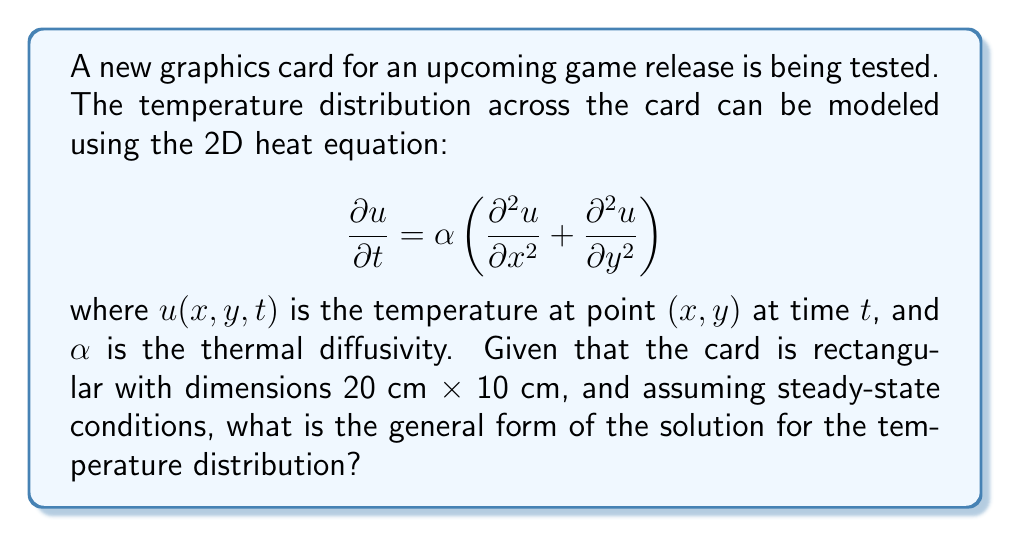Show me your answer to this math problem. To solve this problem, we need to follow these steps:

1) First, we recognize that under steady-state conditions, the temperature doesn't change with time. This means:

   $$\frac{\partial u}{\partial t} = 0$$

2) Substituting this into the original equation:

   $$0 = \alpha\left(\frac{\partial^2 u}{\partial x^2} + \frac{\partial^2 u}{\partial y^2}\right)$$

3) Simplifying:

   $$\frac{\partial^2 u}{\partial x^2} + \frac{\partial^2 u}{\partial y^2} = 0$$

4) This is the Laplace equation in two dimensions. The general solution to this equation is of the form:

   $$u(x,y) = \sum_{n=1}^{\infty} (A_n \sinh(\frac{n\pi x}{L_y}) + B_n \cosh(\frac{n\pi x}{L_y})) \sin(\frac{n\pi y}{L_y})$$

   where $L_x$ and $L_y$ are the dimensions of the rectangle in the x and y directions respectively.

5) In our case, $L_x = 20$ cm and $L_y = 10$ cm. Substituting these values:

   $$u(x,y) = \sum_{n=1}^{\infty} (A_n \sinh(\frac{n\pi x}{10}) + B_n \cosh(\frac{n\pi x}{10})) \sin(\frac{n\pi y}{10})$$

This is the general form of the solution. The coefficients $A_n$ and $B_n$ would be determined by the specific boundary conditions of the problem, which are not provided in this case.
Answer: $$u(x,y) = \sum_{n=1}^{\infty} (A_n \sinh(\frac{n\pi x}{10}) + B_n \cosh(\frac{n\pi x}{10})) \sin(\frac{n\pi y}{10})$$ 